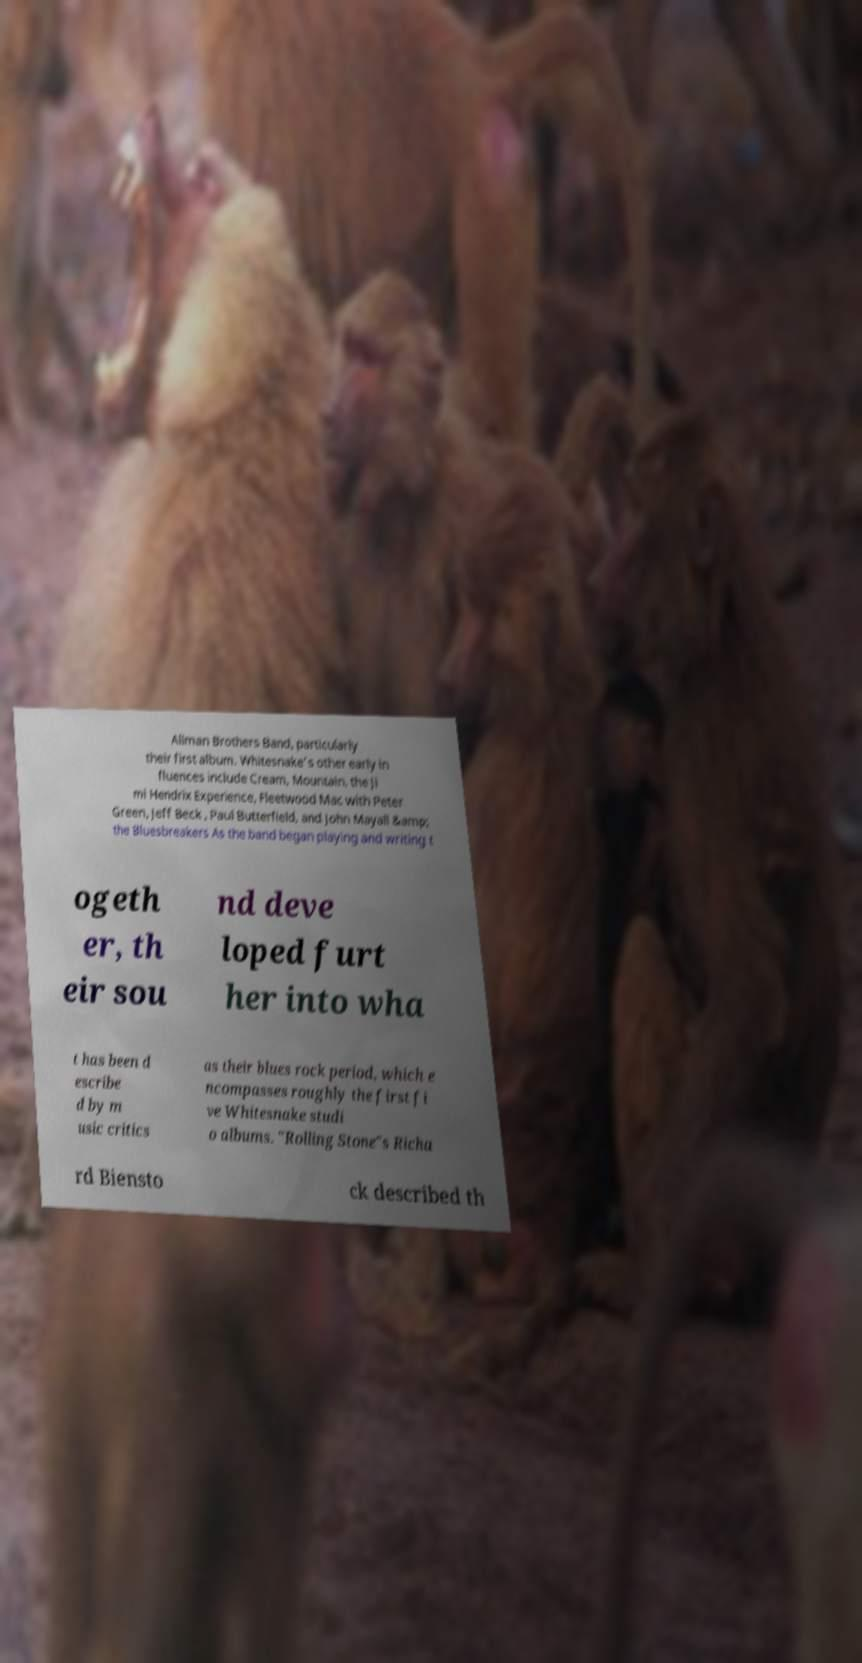I need the written content from this picture converted into text. Can you do that? Allman Brothers Band, particularly their first album. Whitesnake's other early in fluences include Cream, Mountain, the Ji mi Hendrix Experience, Fleetwood Mac with Peter Green, Jeff Beck , Paul Butterfield, and John Mayall &amp; the Bluesbreakers As the band began playing and writing t ogeth er, th eir sou nd deve loped furt her into wha t has been d escribe d by m usic critics as their blues rock period, which e ncompasses roughly the first fi ve Whitesnake studi o albums. "Rolling Stone"s Richa rd Biensto ck described th 